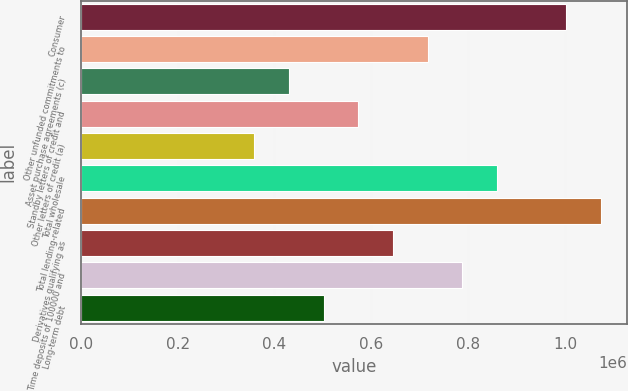Convert chart to OTSL. <chart><loc_0><loc_0><loc_500><loc_500><bar_chart><fcel>Consumer<fcel>Other unfunded commitments to<fcel>Asset purchase agreements (c)<fcel>Standby letters of credit and<fcel>Other letters of credit (a)<fcel>Total wholesale<fcel>Total lending-related<fcel>Derivatives qualifying as<fcel>Time deposits of 100000 and<fcel>Long-term debt<nl><fcel>1.00295e+06<fcel>716424<fcel>429897<fcel>573160<fcel>358265<fcel>859688<fcel>1.07458e+06<fcel>644792<fcel>788056<fcel>501529<nl></chart> 